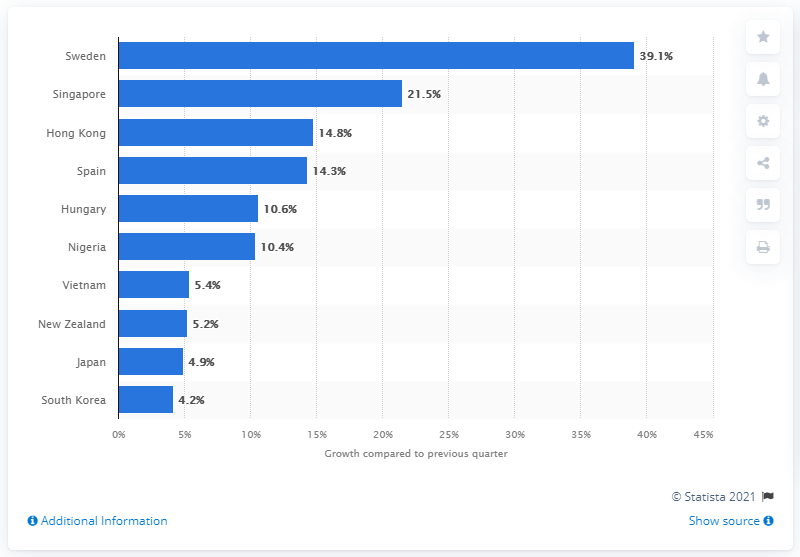Give some essential details in this illustration. The number of downloads of the mobile messaging app increased by 39.1% in Sweden during the first quarter of 2021. 